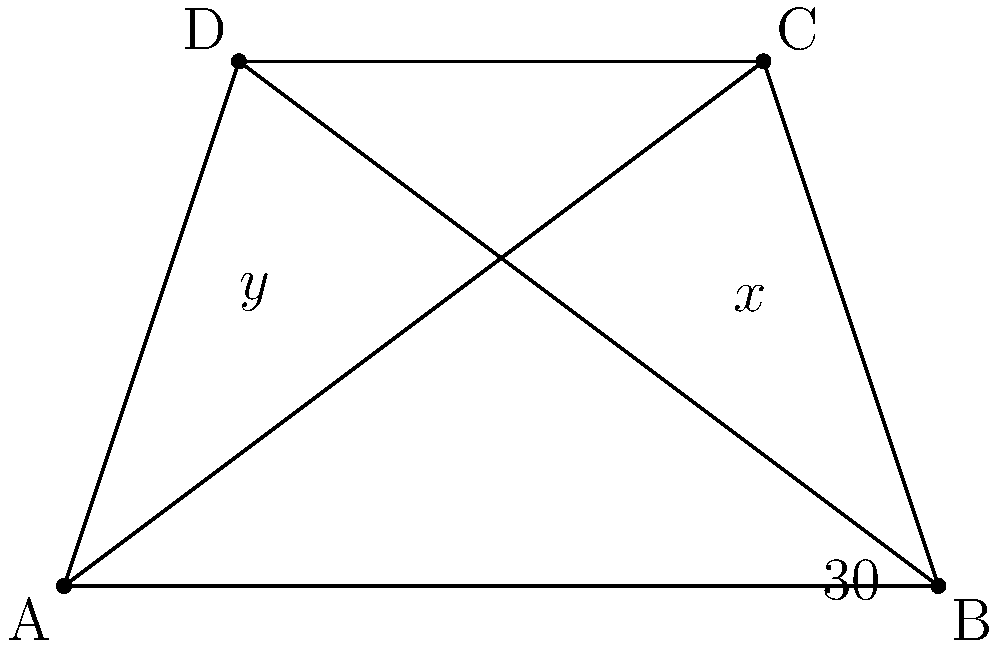On your farm, you're planning to install new fencing that will create intersecting lines. The diagram shows the layout of your property with fence lines forming a quadrilateral ABCD. Given that angle BAC is 30°, and the fence lines AC and BD intersect, what is the sum of angles x and y? Let's approach this step-by-step:

1) In a quadrilateral, the sum of all interior angles is always 360°.

2) When two lines intersect, they form two pairs of vertically opposite angles. Vertically opposite angles are always equal.

3) Let's call the point of intersection of AC and BD as point E.

4) Angle AEB + Angle BEC + Angle CED + Angle DEA = 360° (sum of angles around a point)

5) But Angle AEB = Angle CED (vertically opposite angles)
   And Angle BEC = Angle DEA (vertically opposite angles)

6) So, 2(Angle AEB) + 2(Angle BEC) = 360°
   Or, Angle AEB + Angle BEC = 180°

7) Now, Angle AEB = x° + 30° (Angle BAC is given as 30°)
   And Angle BEC = y°

8) Therefore, (x° + 30°) + y° = 180°
               x° + y° = 150°

Thus, the sum of angles x and y is 150°.
Answer: 150° 